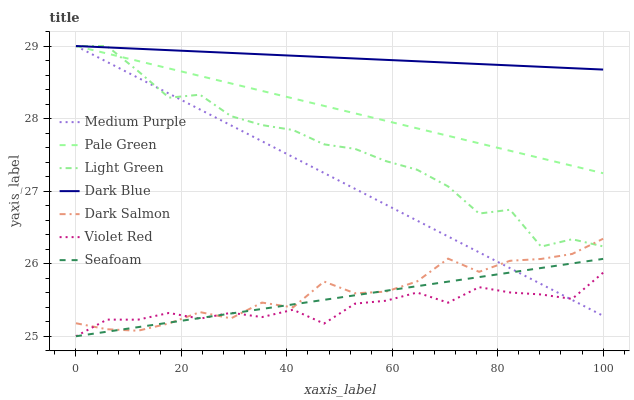Does Dark Salmon have the minimum area under the curve?
Answer yes or no. No. Does Dark Salmon have the maximum area under the curve?
Answer yes or no. No. Is Dark Salmon the smoothest?
Answer yes or no. No. Is Dark Salmon the roughest?
Answer yes or no. No. Does Dark Salmon have the lowest value?
Answer yes or no. No. Does Dark Salmon have the highest value?
Answer yes or no. No. Is Dark Salmon less than Pale Green?
Answer yes or no. Yes. Is Pale Green greater than Seafoam?
Answer yes or no. Yes. Does Dark Salmon intersect Pale Green?
Answer yes or no. No. 